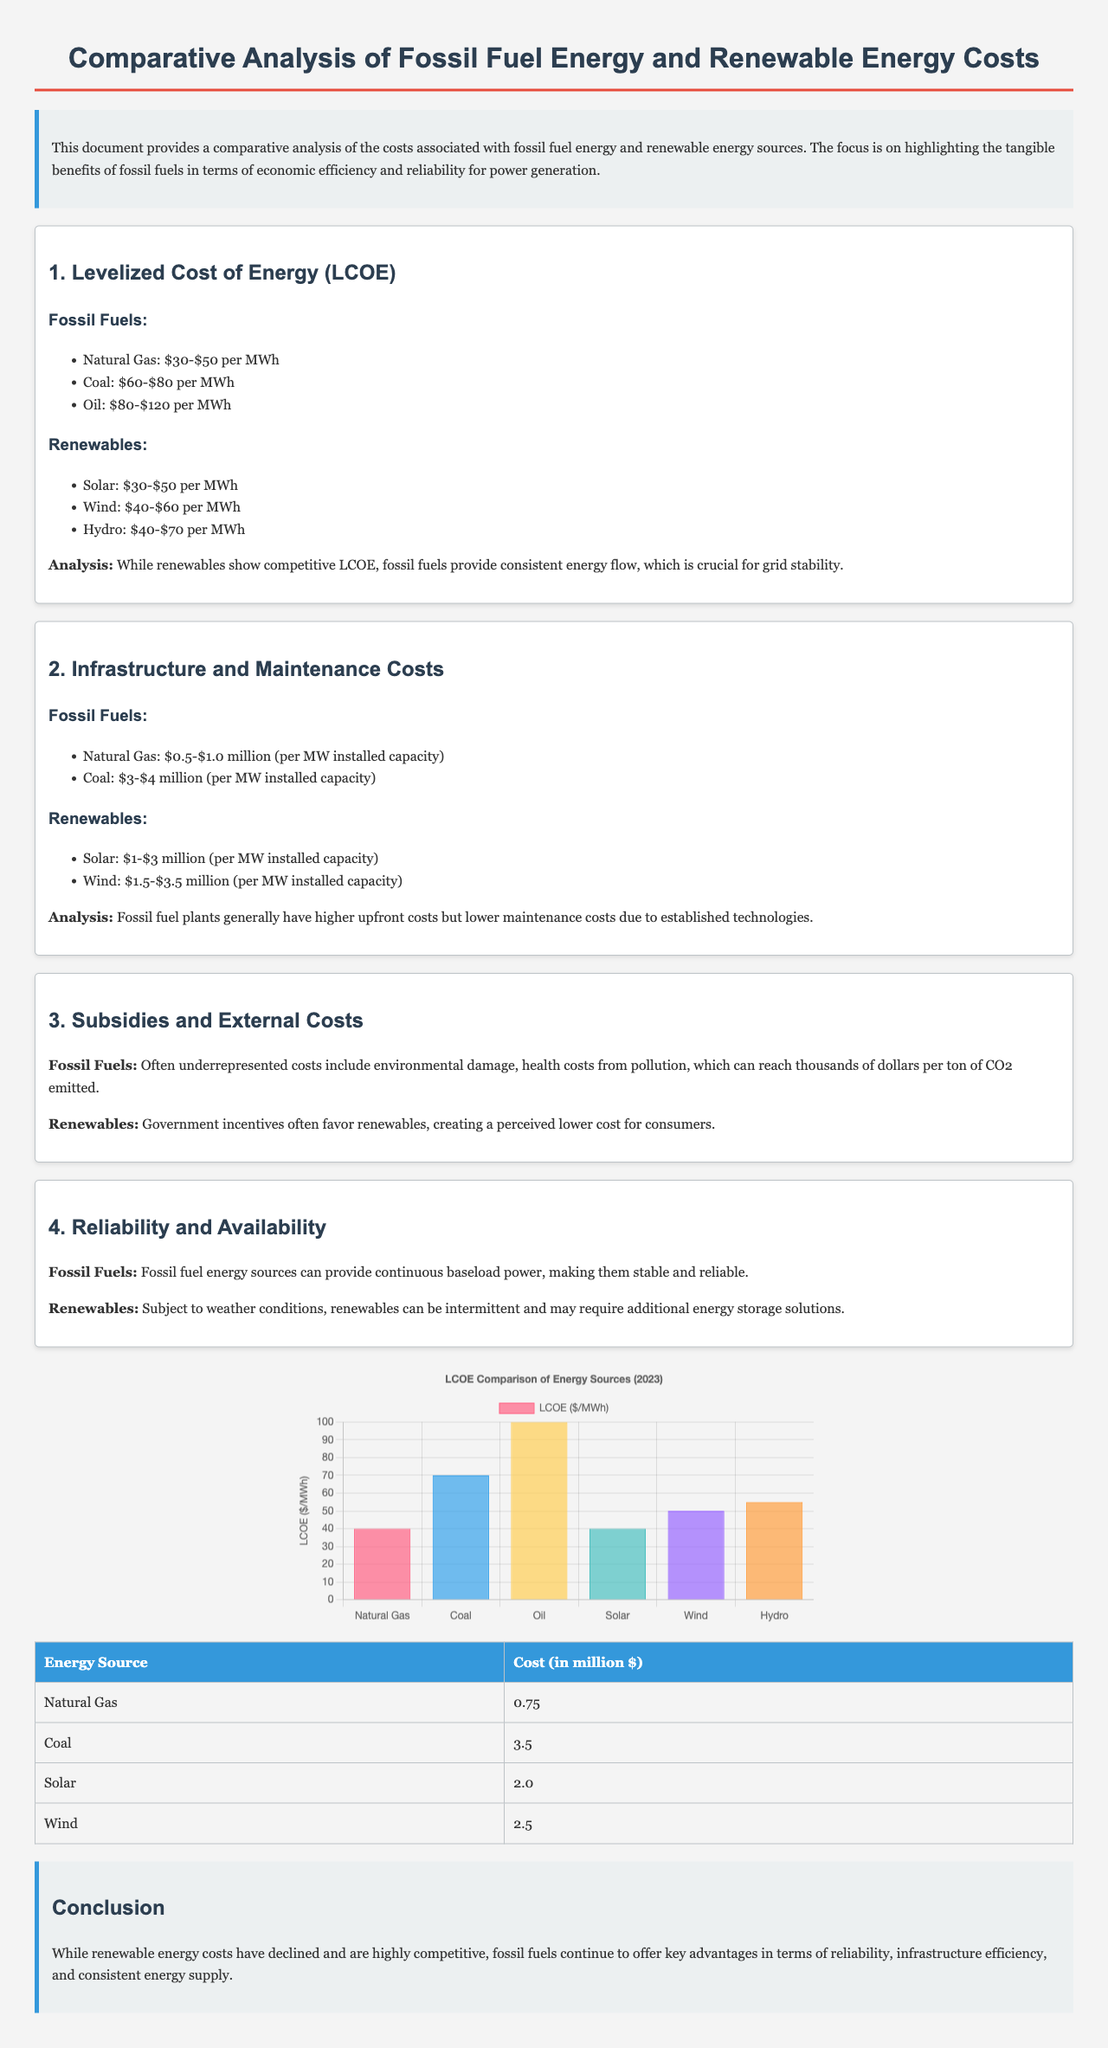What is the LCOE range for Natural Gas? The document states that the LCOE for Natural Gas is between $30 and $50 per MWh.
Answer: $30-$50 per MWh What are the infrastructure costs for Coal? The document lists the infrastructure costs for Coal as $3 to $4 million per MW installed capacity.
Answer: $3-$4 million per MW Which renewable energy source has a higher LCOE than Natural Gas? According to the data, the only renewable source that can have a higher LCOE than Natural Gas is Oil with $80-$120 per MWh.
Answer: Oil What is the LCOE for Hydro energy? The LCOE for Hydro energy is stated as $40-$70 per MWh.
Answer: $40-$70 per MWh What are the maintenance costs for Solar energy? The document mentions that the maintenance costs for Solar are between $1 and $3 million per MW installed capacity.
Answer: $1-$3 million per MW What type of power do fossil fuels provide according to the analysis? The document indicates that fossil fuels provide continuous baseload power.
Answer: Baseload power What is the color of the chart representing LCOE Comparison? The chart utilizes various colors for different energy sources, with red for Natural Gas, blue for Coal, and so on.
Answer: Various colors Which section discusses subsidies and external costs? The section titled "3. Subsidies and External Costs" addresses this topic.
Answer: 3. Subsidies and External Costs 